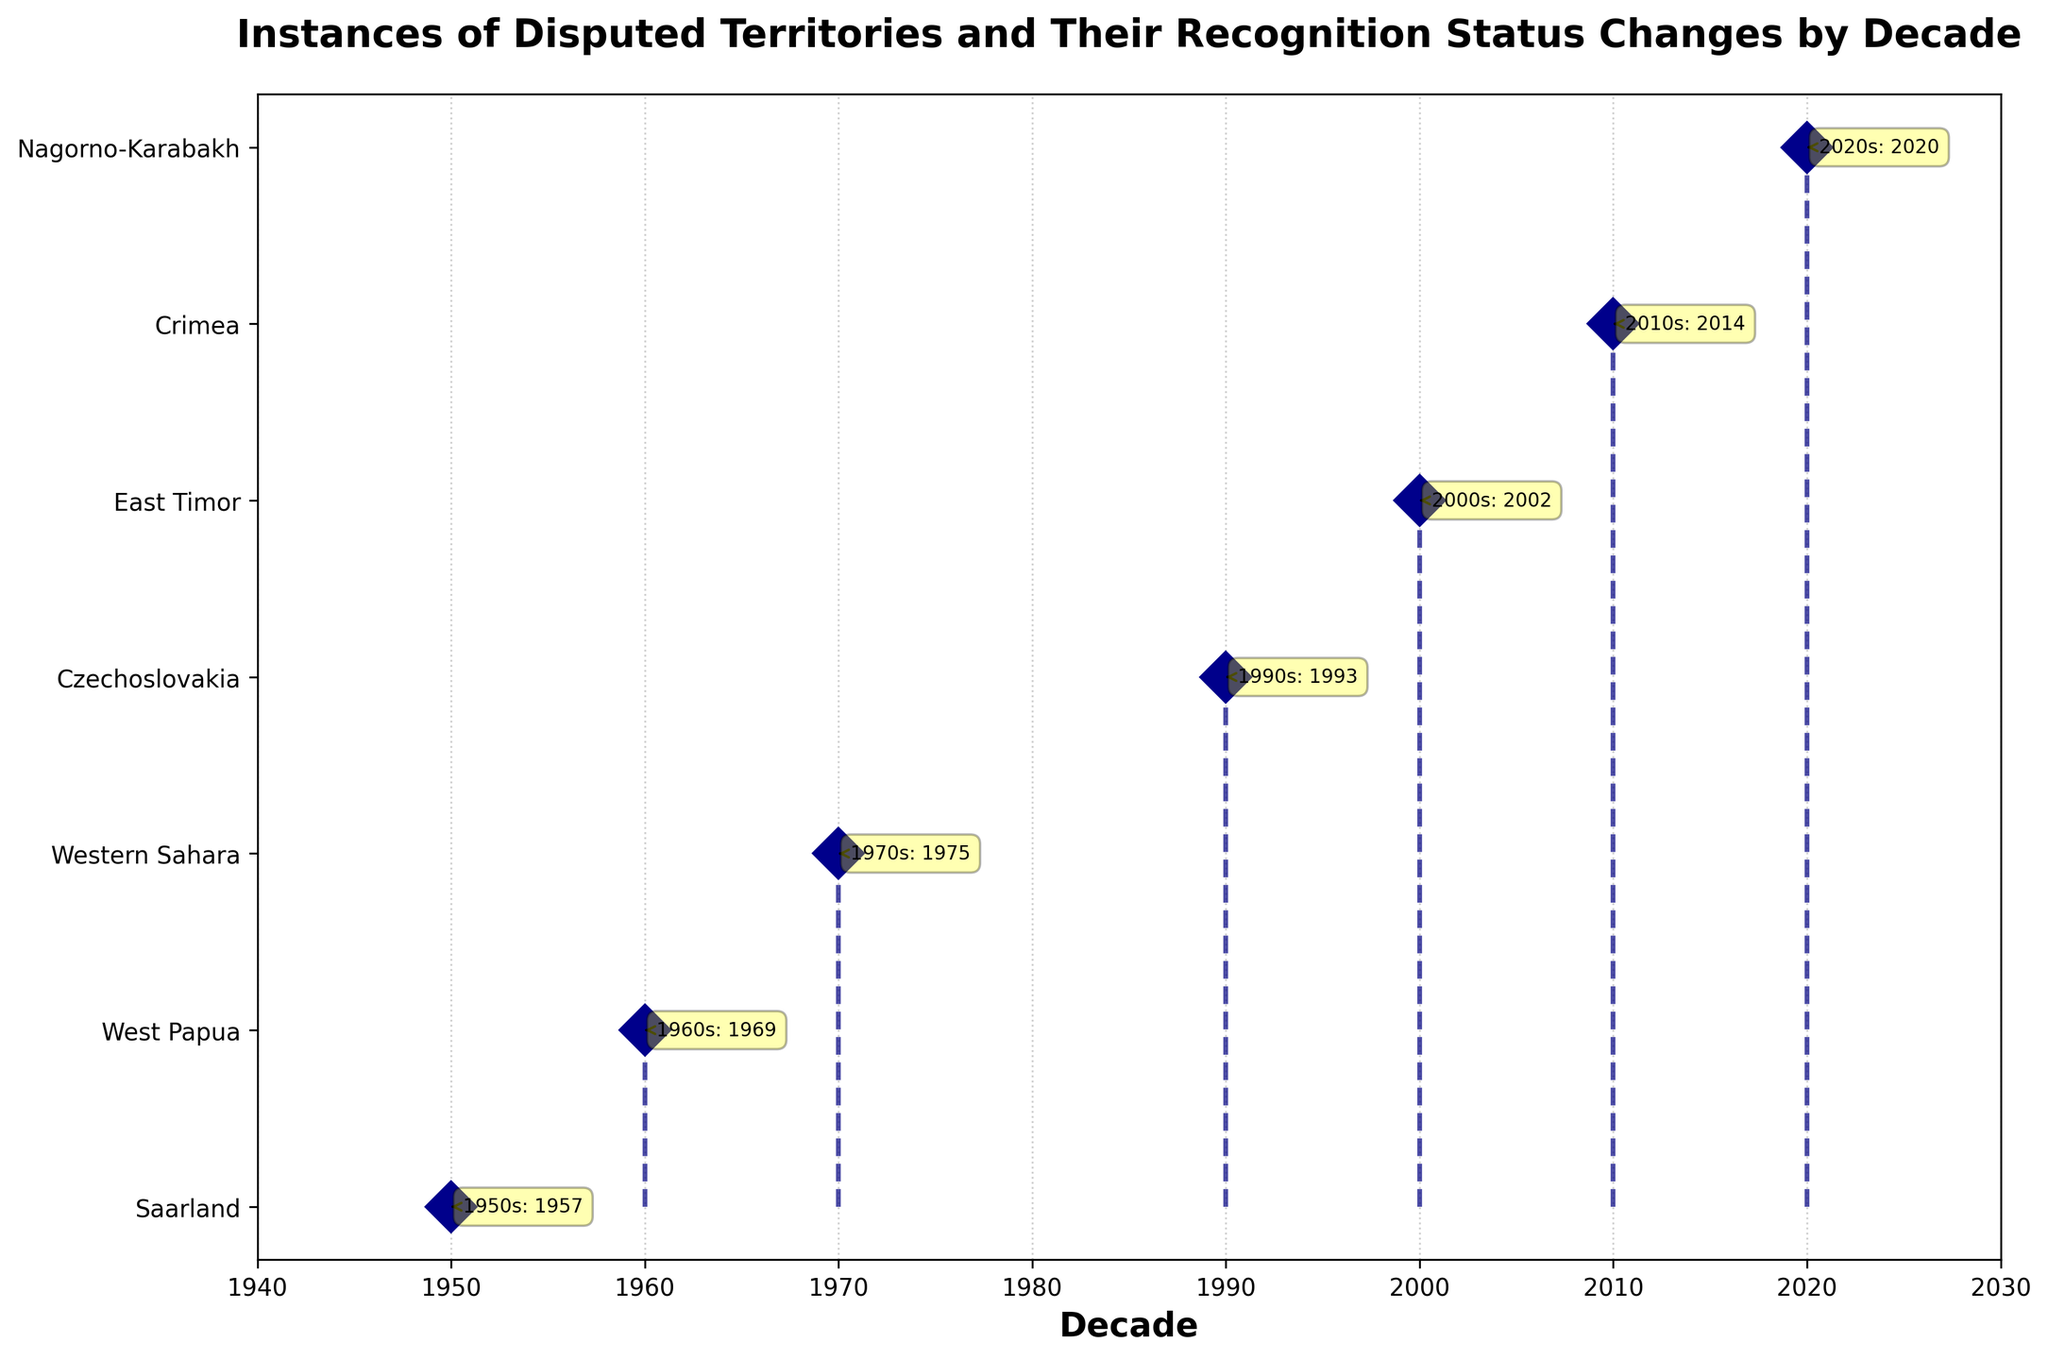What is the title of the plot? The title is usually displayed at the top of the plot. It provides a summary of what the plot represents.
Answer: Instances of Disputed Territories and Their Recognition Status Changes by Decade Which decade has the most recent recognition status change? To determine the most recent recognition status change, look for the latest decade label on the x-axis and match it with the corresponding y-axis label.
Answer: 2020s How many disputed territories are shown in the plot? Count the number of unique y-axis labels that represent each disputed territory.
Answer: Seven Which disputed territory changed recognition status in 2002? Locate the annotation for 2002 by finding the year along the x-axis and reading the corresponding y-axis label for the territory.
Answer: East Timor What is the previous recognition status of Crimea before 2014? Reference the annotation for the year 2014 and read the descriptive label pertaining to Crimea's previous recognition status.
Answer: Part of Ukraine Which two countries formed from Czechoslovakia's recognition change in 1993? Review the annotation for 1993 and read the details about Czechoslovakia's status change.
Answer: Czech Republic and Slovakia How many decades are covered in this plot? Identify all the unique decades listed on the x-axis.
Answer: Seven What is the color of the stem lines in the plot? Observe the visual characteristics of the stem lines connecting the data points to the baseline.
Answer: Navy Which disputed territory is annotated as having a disputed status by Morocco and the Sahrawi Arab Democratic Republic? Find the annotation describing this status change and match it with the y-axis label for the disputed territory.
Answer: Western Sahara Between Crimean recognition status change and Nagorno-Karabakh recognition status change, which occurred earlier? Compare the years annotated for Crimea and Nagorno-Karabakh and determine which is earlier.
Answer: Crimea's status change in 2014 